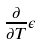<formula> <loc_0><loc_0><loc_500><loc_500>\frac { \partial } { \partial T } \epsilon</formula> 